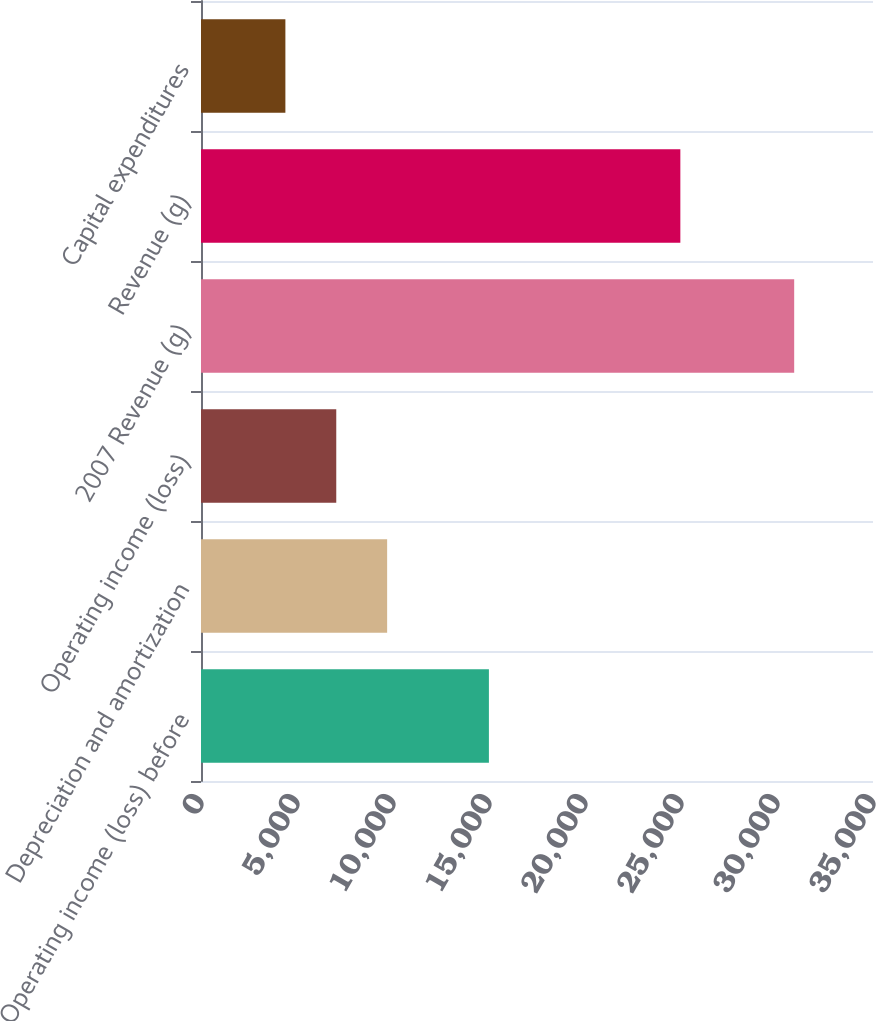Convert chart. <chart><loc_0><loc_0><loc_500><loc_500><bar_chart><fcel>Operating income (loss) before<fcel>Depreciation and amortization<fcel>Operating income (loss)<fcel>2007 Revenue (g)<fcel>Revenue (g)<fcel>Capital expenditures<nl><fcel>14995<fcel>9695<fcel>7045<fcel>30895<fcel>24966<fcel>4395<nl></chart> 